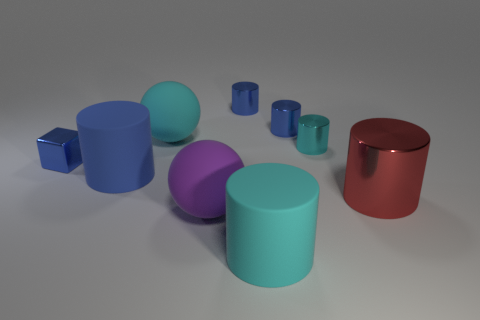Is the number of small green shiny objects less than the number of purple balls?
Offer a very short reply. Yes. Does the large blue thing that is in front of the tiny block have the same material as the block in front of the tiny cyan object?
Provide a succinct answer. No. Are there fewer small metal objects that are in front of the small blue metal block than large blue cylinders?
Make the answer very short. Yes. How many big things are left of the matte ball behind the blue block?
Provide a short and direct response. 1. How big is the cylinder that is both on the left side of the tiny cyan thing and to the right of the cyan matte cylinder?
Keep it short and to the point. Small. Is the large blue thing made of the same material as the large ball in front of the red metal cylinder?
Ensure brevity in your answer.  Yes. Are there fewer blue metallic things that are left of the blue matte cylinder than tiny cyan shiny things on the right side of the red shiny cylinder?
Ensure brevity in your answer.  No. What is the blue cylinder that is in front of the small blue cube made of?
Your answer should be compact. Rubber. What color is the object that is in front of the small block and to the right of the big cyan cylinder?
Ensure brevity in your answer.  Red. What number of other things are the same color as the block?
Give a very brief answer. 3. 